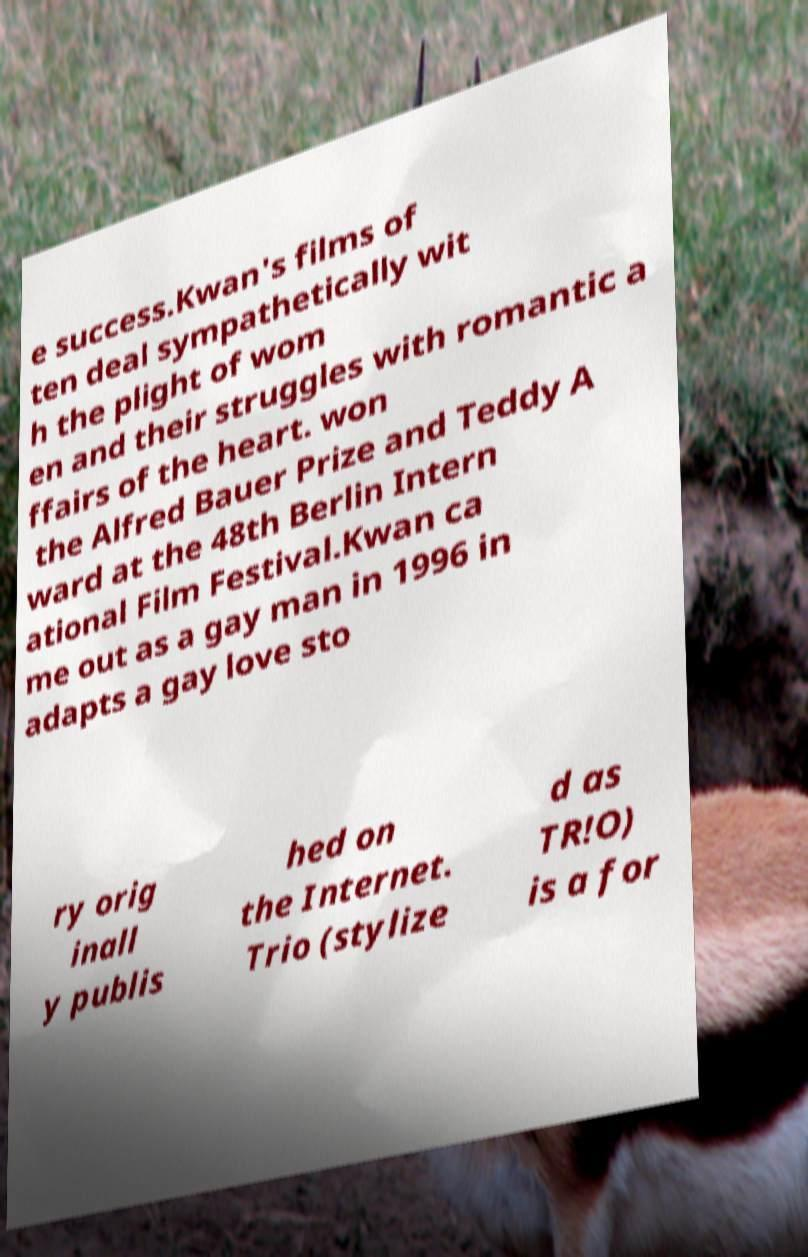Can you accurately transcribe the text from the provided image for me? e success.Kwan's films of ten deal sympathetically wit h the plight of wom en and their struggles with romantic a ffairs of the heart. won the Alfred Bauer Prize and Teddy A ward at the 48th Berlin Intern ational Film Festival.Kwan ca me out as a gay man in 1996 in adapts a gay love sto ry orig inall y publis hed on the Internet. Trio (stylize d as TR!O) is a for 